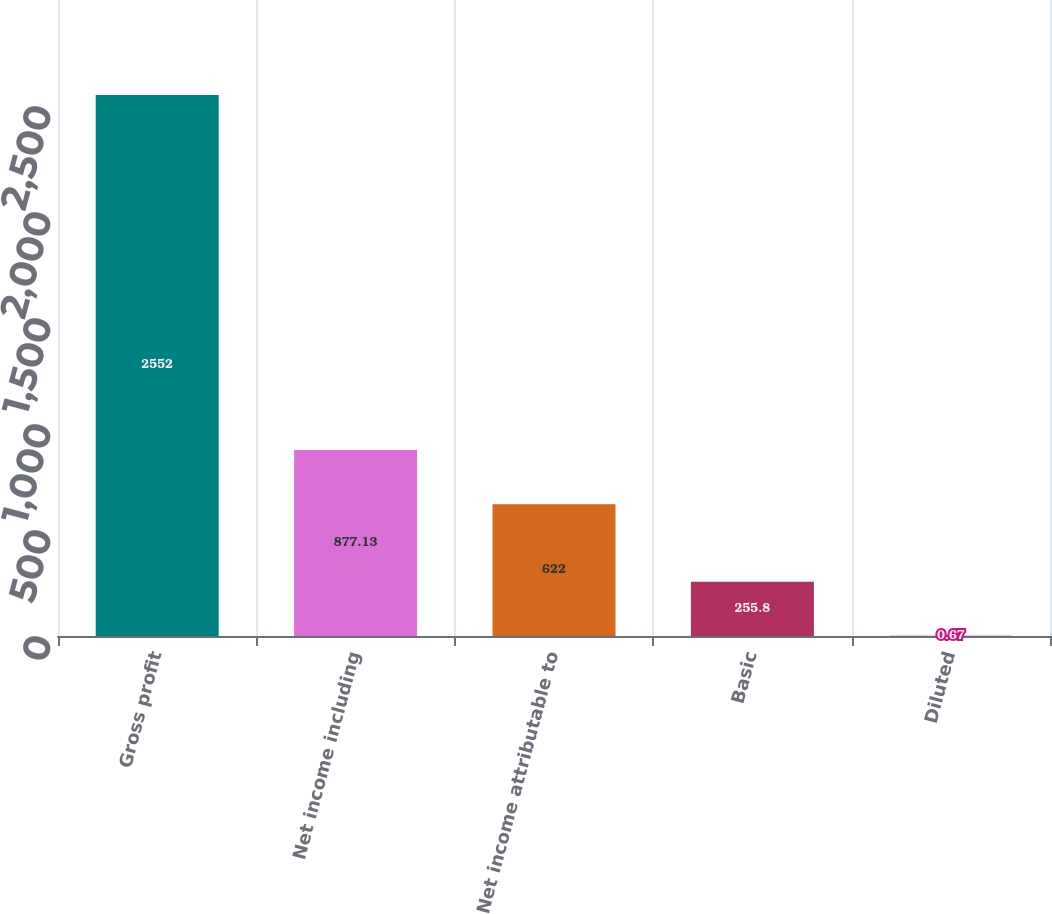Convert chart. <chart><loc_0><loc_0><loc_500><loc_500><bar_chart><fcel>Gross profit<fcel>Net income including<fcel>Net income attributable to<fcel>Basic<fcel>Diluted<nl><fcel>2552<fcel>877.13<fcel>622<fcel>255.8<fcel>0.67<nl></chart> 